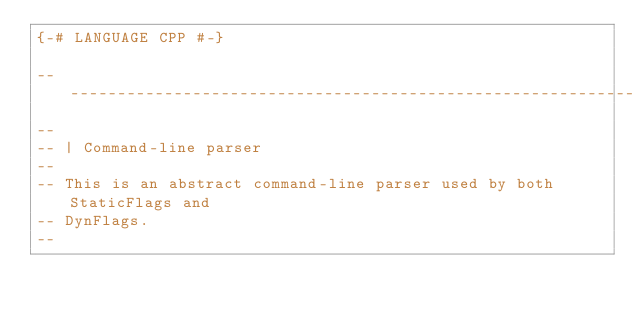<code> <loc_0><loc_0><loc_500><loc_500><_Haskell_>{-# LANGUAGE CPP #-}

-------------------------------------------------------------------------------
--
-- | Command-line parser
--
-- This is an abstract command-line parser used by both StaticFlags and
-- DynFlags.
--</code> 